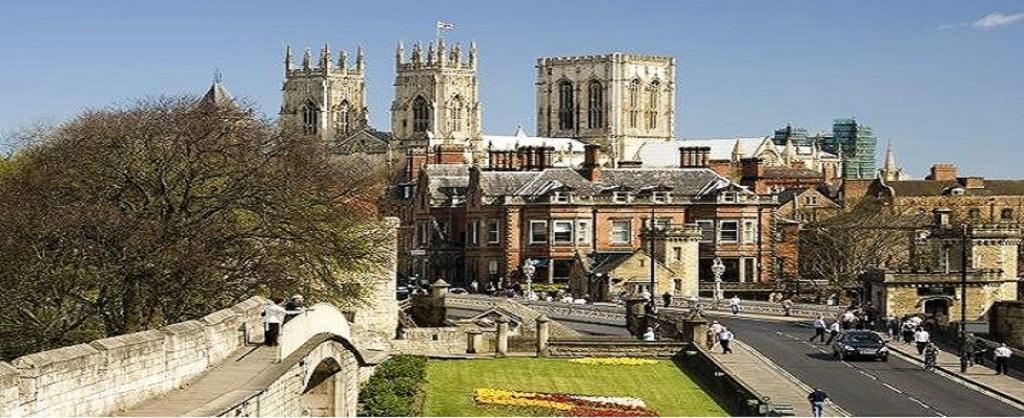Can you describe this image briefly? In this image, we can see so many buildings, trees, poles, walkways, plants, grass and people. On the right side of the image, we can see a car is on the road. Background there is the sky. 